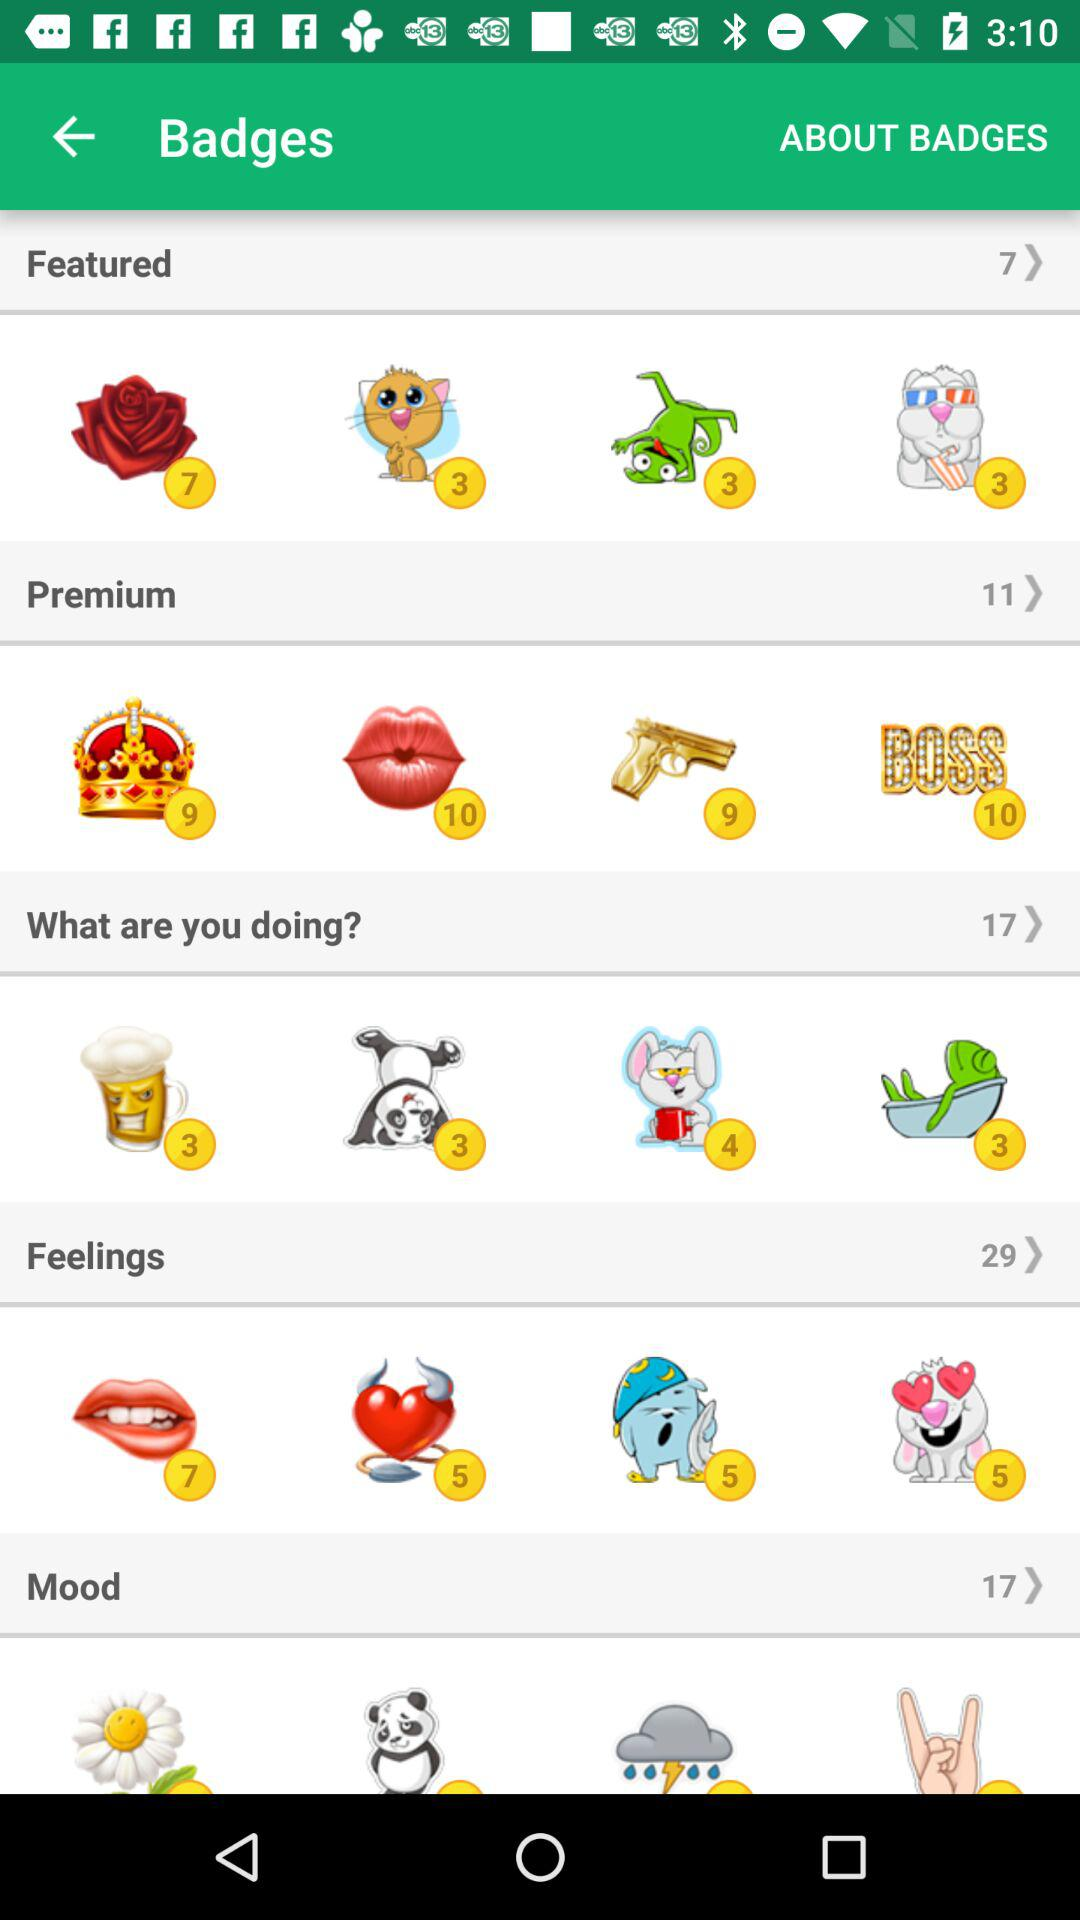What is the total number of "Feelings" stickers? The total number of "Feelings" stickers is 29. 